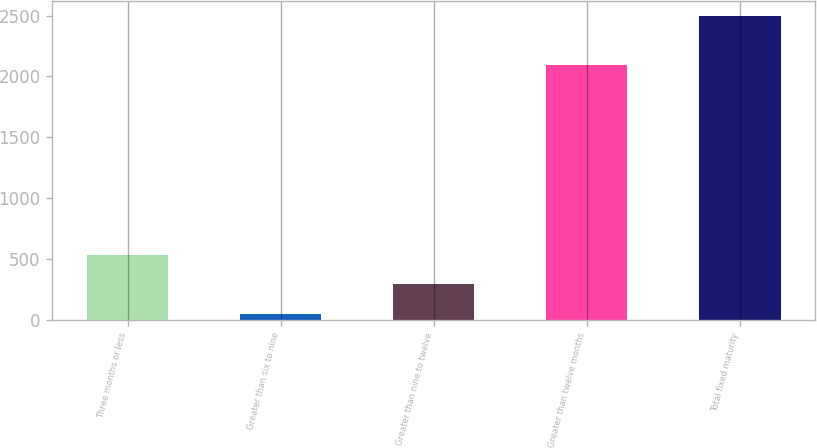<chart> <loc_0><loc_0><loc_500><loc_500><bar_chart><fcel>Three months or less<fcel>Greater than six to nine<fcel>Greater than nine to twelve<fcel>Greater than twelve months<fcel>Total fixed maturity<nl><fcel>536.1<fcel>46.1<fcel>291.1<fcel>2089.6<fcel>2496.1<nl></chart> 